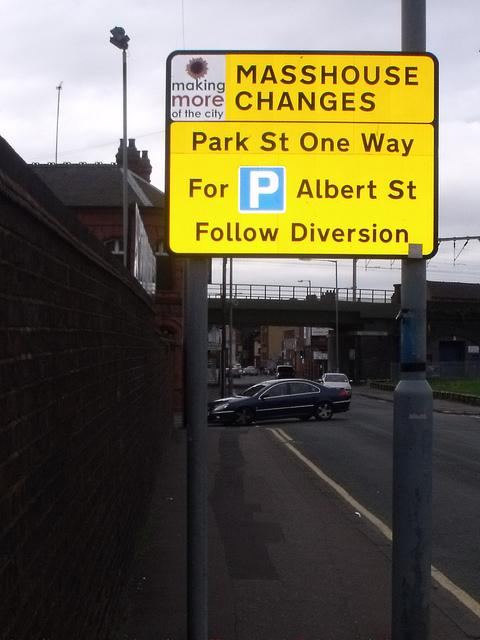Why is the yellow sign posted outdoors?

Choices:
A) to scare
B) to inform
C) to protest
D) to sell to inform 